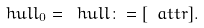Convert formula to latex. <formula><loc_0><loc_0><loc_500><loc_500>\ h u l l _ { 0 } = \ h u l l \colon = [ \ a t t r ] .</formula> 